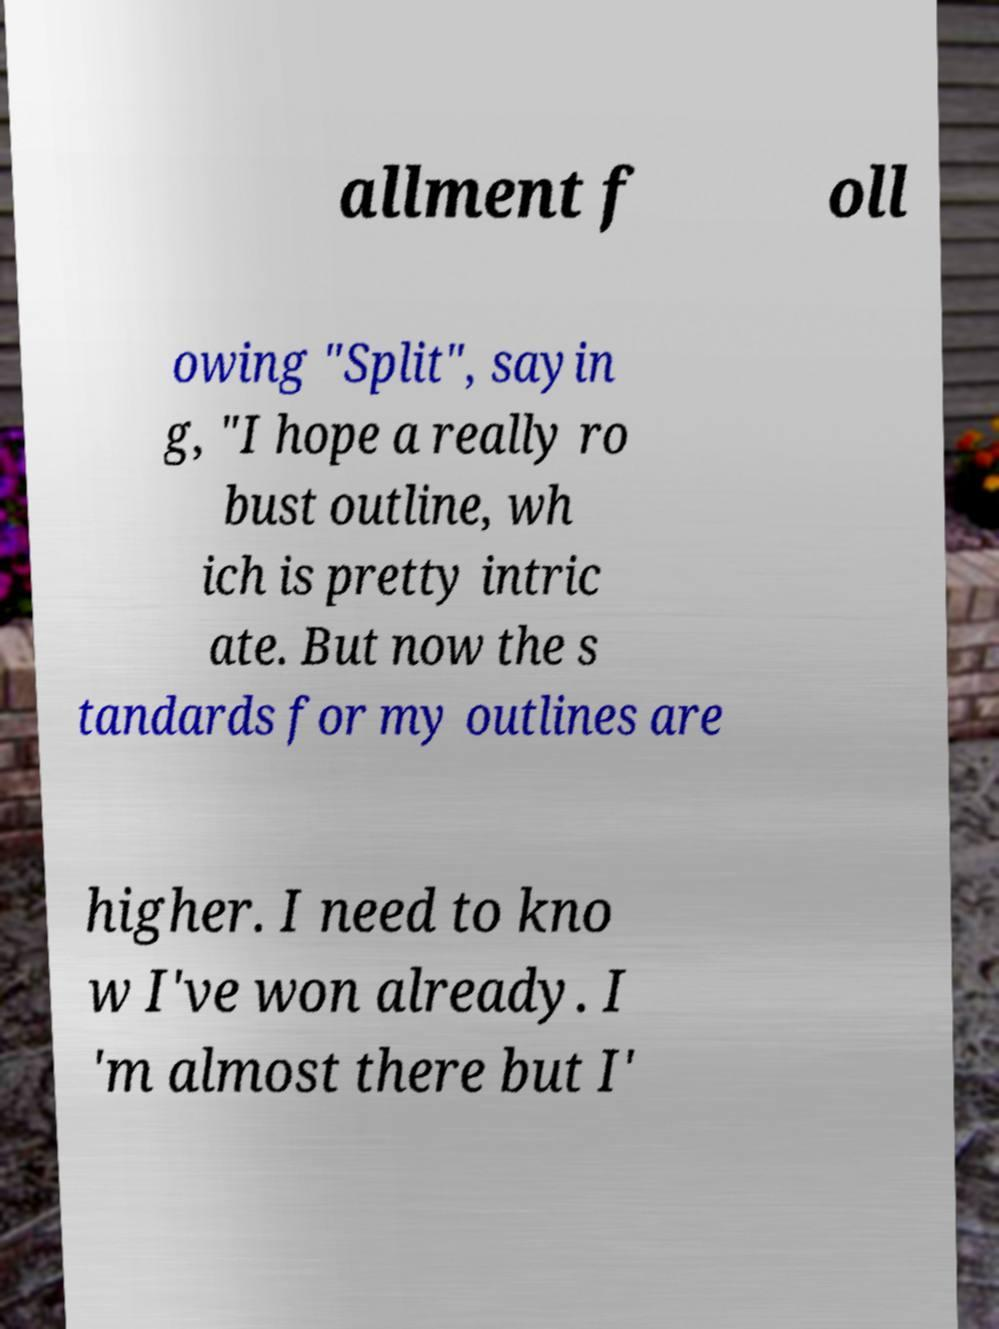There's text embedded in this image that I need extracted. Can you transcribe it verbatim? allment f oll owing "Split", sayin g, "I hope a really ro bust outline, wh ich is pretty intric ate. But now the s tandards for my outlines are higher. I need to kno w I've won already. I 'm almost there but I' 